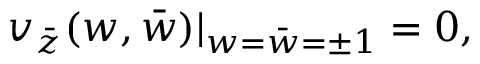<formula> <loc_0><loc_0><loc_500><loc_500>v _ { \bar { z } } ( w , \bar { w } ) | _ { w = \bar { w } = \pm 1 } = 0 ,</formula> 